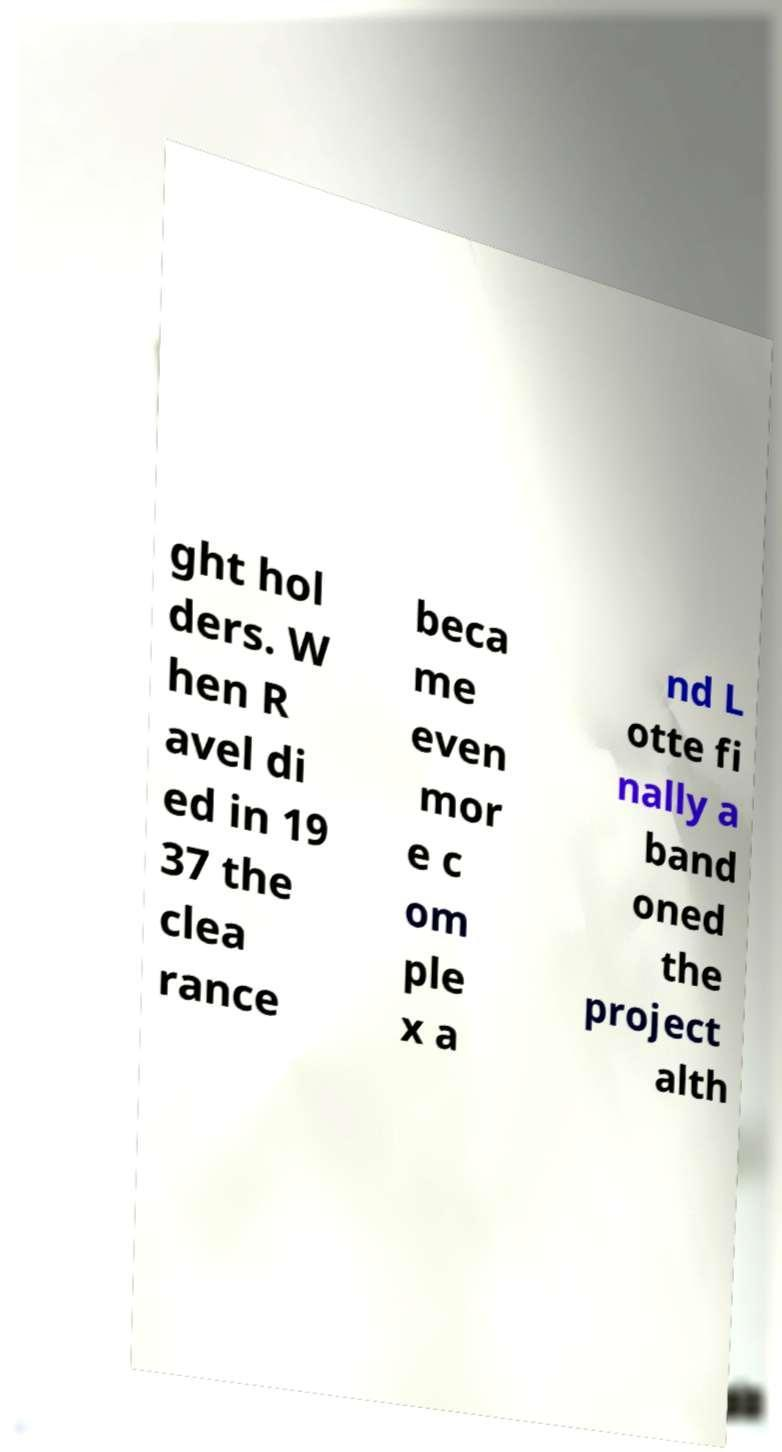There's text embedded in this image that I need extracted. Can you transcribe it verbatim? ght hol ders. W hen R avel di ed in 19 37 the clea rance beca me even mor e c om ple x a nd L otte fi nally a band oned the project alth 